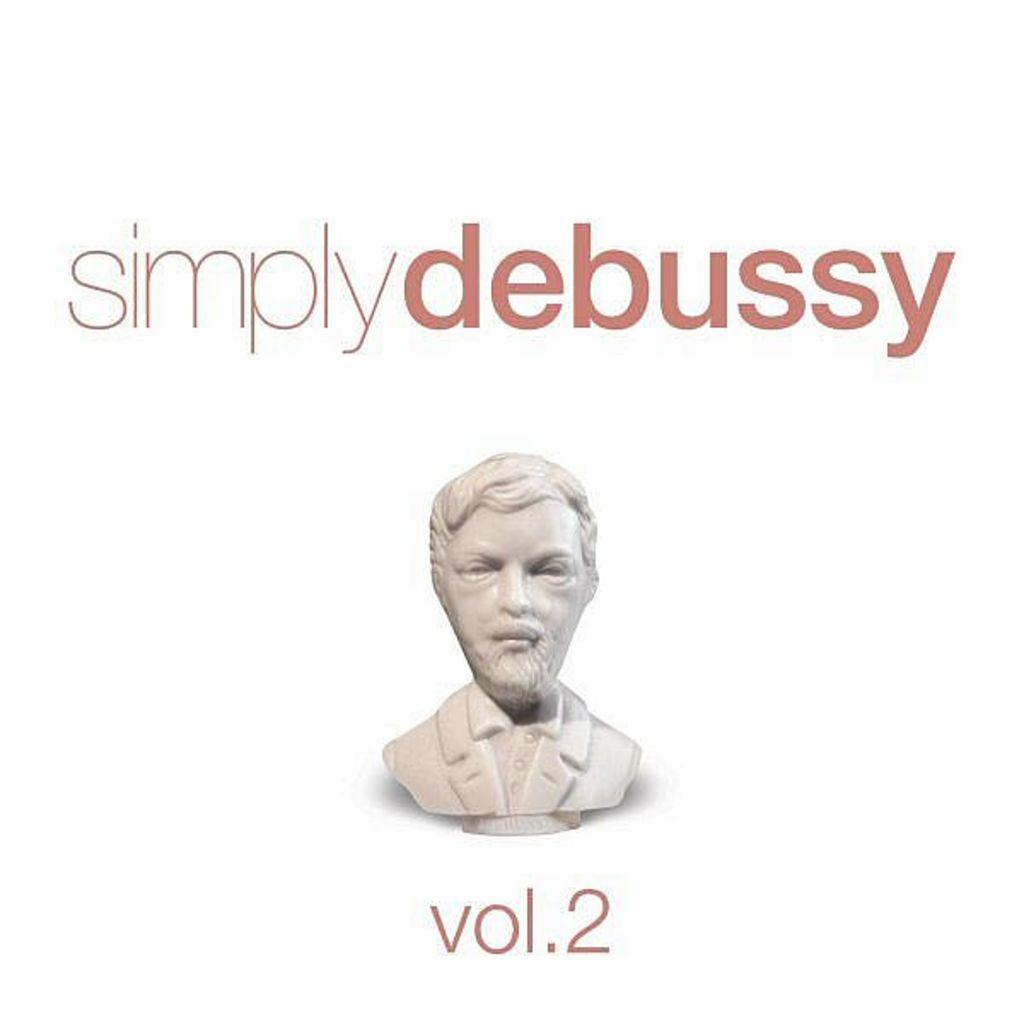What is the main subject of the image? There is a white colored statue in the image. What is the statue depicting? The statue is of a person. What is the person in the statue wearing? The person is wearing a blazer. What color is the background of the image? The background of the image is white. What color are the words written in the image? The words written in the image are brown. How does the statue compare to a rainstorm in the image? There is no rainstorm present in the image, so it cannot be compared to the statue. 